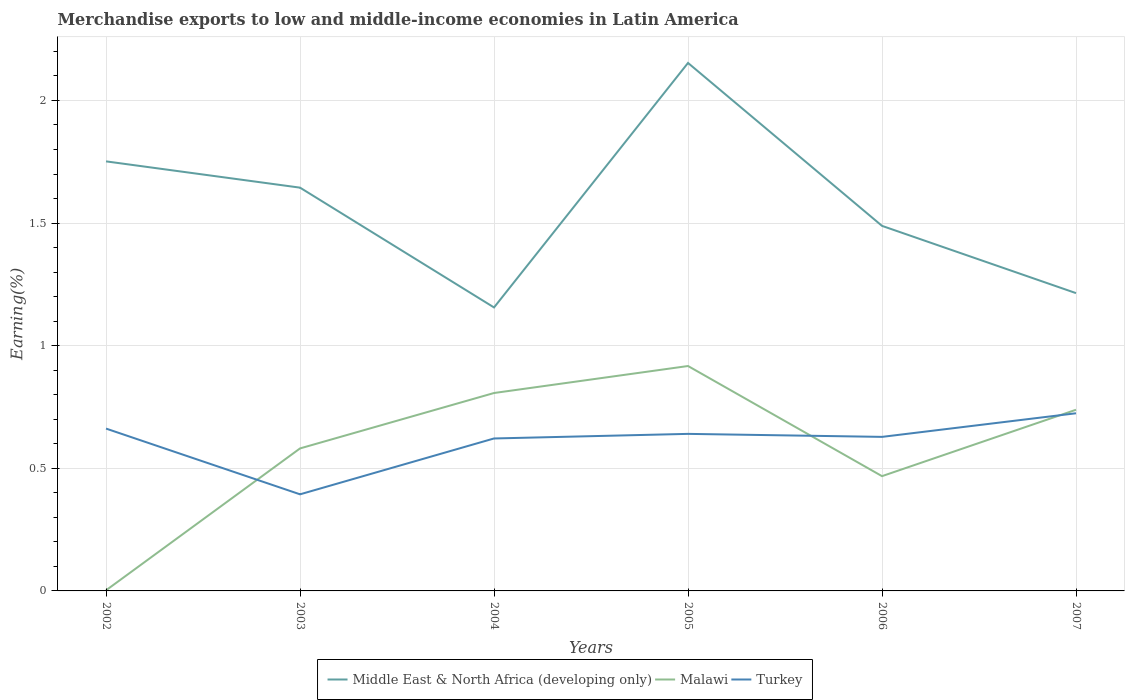How many different coloured lines are there?
Your answer should be very brief. 3. Does the line corresponding to Middle East & North Africa (developing only) intersect with the line corresponding to Malawi?
Keep it short and to the point. No. Across all years, what is the maximum percentage of amount earned from merchandise exports in Turkey?
Provide a short and direct response. 0.39. What is the total percentage of amount earned from merchandise exports in Middle East & North Africa (developing only) in the graph?
Your answer should be very brief. 0.6. What is the difference between the highest and the second highest percentage of amount earned from merchandise exports in Malawi?
Offer a terse response. 0.91. What is the difference between the highest and the lowest percentage of amount earned from merchandise exports in Middle East & North Africa (developing only)?
Provide a short and direct response. 3. Is the percentage of amount earned from merchandise exports in Malawi strictly greater than the percentage of amount earned from merchandise exports in Turkey over the years?
Offer a very short reply. No. How many years are there in the graph?
Provide a succinct answer. 6. What is the difference between two consecutive major ticks on the Y-axis?
Offer a terse response. 0.5. Does the graph contain any zero values?
Your answer should be compact. No. Where does the legend appear in the graph?
Offer a terse response. Bottom center. What is the title of the graph?
Offer a very short reply. Merchandise exports to low and middle-income economies in Latin America. Does "Ghana" appear as one of the legend labels in the graph?
Provide a succinct answer. No. What is the label or title of the Y-axis?
Keep it short and to the point. Earning(%). What is the Earning(%) of Middle East & North Africa (developing only) in 2002?
Make the answer very short. 1.75. What is the Earning(%) of Malawi in 2002?
Keep it short and to the point. 0. What is the Earning(%) of Turkey in 2002?
Give a very brief answer. 0.66. What is the Earning(%) of Middle East & North Africa (developing only) in 2003?
Make the answer very short. 1.64. What is the Earning(%) of Malawi in 2003?
Your answer should be very brief. 0.58. What is the Earning(%) in Turkey in 2003?
Make the answer very short. 0.39. What is the Earning(%) of Middle East & North Africa (developing only) in 2004?
Your answer should be compact. 1.16. What is the Earning(%) in Malawi in 2004?
Your answer should be compact. 0.81. What is the Earning(%) of Turkey in 2004?
Ensure brevity in your answer.  0.62. What is the Earning(%) in Middle East & North Africa (developing only) in 2005?
Provide a short and direct response. 2.15. What is the Earning(%) in Malawi in 2005?
Your answer should be compact. 0.92. What is the Earning(%) of Turkey in 2005?
Your response must be concise. 0.64. What is the Earning(%) of Middle East & North Africa (developing only) in 2006?
Offer a terse response. 1.49. What is the Earning(%) in Malawi in 2006?
Ensure brevity in your answer.  0.47. What is the Earning(%) in Turkey in 2006?
Ensure brevity in your answer.  0.63. What is the Earning(%) of Middle East & North Africa (developing only) in 2007?
Your answer should be compact. 1.21. What is the Earning(%) of Malawi in 2007?
Give a very brief answer. 0.74. What is the Earning(%) in Turkey in 2007?
Keep it short and to the point. 0.72. Across all years, what is the maximum Earning(%) of Middle East & North Africa (developing only)?
Your answer should be compact. 2.15. Across all years, what is the maximum Earning(%) in Malawi?
Keep it short and to the point. 0.92. Across all years, what is the maximum Earning(%) in Turkey?
Provide a short and direct response. 0.72. Across all years, what is the minimum Earning(%) in Middle East & North Africa (developing only)?
Offer a very short reply. 1.16. Across all years, what is the minimum Earning(%) in Malawi?
Offer a very short reply. 0. Across all years, what is the minimum Earning(%) of Turkey?
Ensure brevity in your answer.  0.39. What is the total Earning(%) of Middle East & North Africa (developing only) in the graph?
Offer a very short reply. 9.41. What is the total Earning(%) in Malawi in the graph?
Make the answer very short. 3.51. What is the total Earning(%) of Turkey in the graph?
Your answer should be very brief. 3.67. What is the difference between the Earning(%) in Middle East & North Africa (developing only) in 2002 and that in 2003?
Your answer should be compact. 0.11. What is the difference between the Earning(%) of Malawi in 2002 and that in 2003?
Provide a succinct answer. -0.58. What is the difference between the Earning(%) of Turkey in 2002 and that in 2003?
Give a very brief answer. 0.27. What is the difference between the Earning(%) of Middle East & North Africa (developing only) in 2002 and that in 2004?
Provide a short and direct response. 0.6. What is the difference between the Earning(%) of Malawi in 2002 and that in 2004?
Provide a succinct answer. -0.8. What is the difference between the Earning(%) in Turkey in 2002 and that in 2004?
Offer a very short reply. 0.04. What is the difference between the Earning(%) of Middle East & North Africa (developing only) in 2002 and that in 2005?
Ensure brevity in your answer.  -0.4. What is the difference between the Earning(%) in Malawi in 2002 and that in 2005?
Offer a terse response. -0.91. What is the difference between the Earning(%) in Turkey in 2002 and that in 2005?
Keep it short and to the point. 0.02. What is the difference between the Earning(%) of Middle East & North Africa (developing only) in 2002 and that in 2006?
Offer a terse response. 0.26. What is the difference between the Earning(%) of Malawi in 2002 and that in 2006?
Make the answer very short. -0.47. What is the difference between the Earning(%) of Turkey in 2002 and that in 2006?
Your answer should be very brief. 0.03. What is the difference between the Earning(%) of Middle East & North Africa (developing only) in 2002 and that in 2007?
Your response must be concise. 0.54. What is the difference between the Earning(%) in Malawi in 2002 and that in 2007?
Your answer should be very brief. -0.74. What is the difference between the Earning(%) in Turkey in 2002 and that in 2007?
Ensure brevity in your answer.  -0.06. What is the difference between the Earning(%) in Middle East & North Africa (developing only) in 2003 and that in 2004?
Your response must be concise. 0.49. What is the difference between the Earning(%) of Malawi in 2003 and that in 2004?
Your answer should be very brief. -0.23. What is the difference between the Earning(%) in Turkey in 2003 and that in 2004?
Provide a short and direct response. -0.23. What is the difference between the Earning(%) in Middle East & North Africa (developing only) in 2003 and that in 2005?
Provide a short and direct response. -0.51. What is the difference between the Earning(%) in Malawi in 2003 and that in 2005?
Your answer should be compact. -0.34. What is the difference between the Earning(%) of Turkey in 2003 and that in 2005?
Provide a succinct answer. -0.25. What is the difference between the Earning(%) in Middle East & North Africa (developing only) in 2003 and that in 2006?
Provide a short and direct response. 0.16. What is the difference between the Earning(%) of Malawi in 2003 and that in 2006?
Provide a short and direct response. 0.11. What is the difference between the Earning(%) in Turkey in 2003 and that in 2006?
Provide a succinct answer. -0.23. What is the difference between the Earning(%) in Middle East & North Africa (developing only) in 2003 and that in 2007?
Provide a short and direct response. 0.43. What is the difference between the Earning(%) in Malawi in 2003 and that in 2007?
Make the answer very short. -0.16. What is the difference between the Earning(%) of Turkey in 2003 and that in 2007?
Give a very brief answer. -0.33. What is the difference between the Earning(%) of Middle East & North Africa (developing only) in 2004 and that in 2005?
Keep it short and to the point. -1. What is the difference between the Earning(%) of Malawi in 2004 and that in 2005?
Your answer should be very brief. -0.11. What is the difference between the Earning(%) in Turkey in 2004 and that in 2005?
Your answer should be very brief. -0.02. What is the difference between the Earning(%) in Middle East & North Africa (developing only) in 2004 and that in 2006?
Your answer should be compact. -0.33. What is the difference between the Earning(%) of Malawi in 2004 and that in 2006?
Provide a short and direct response. 0.34. What is the difference between the Earning(%) of Turkey in 2004 and that in 2006?
Provide a short and direct response. -0.01. What is the difference between the Earning(%) of Middle East & North Africa (developing only) in 2004 and that in 2007?
Provide a succinct answer. -0.06. What is the difference between the Earning(%) in Malawi in 2004 and that in 2007?
Offer a terse response. 0.07. What is the difference between the Earning(%) in Turkey in 2004 and that in 2007?
Your answer should be very brief. -0.1. What is the difference between the Earning(%) of Middle East & North Africa (developing only) in 2005 and that in 2006?
Keep it short and to the point. 0.66. What is the difference between the Earning(%) in Malawi in 2005 and that in 2006?
Give a very brief answer. 0.45. What is the difference between the Earning(%) in Turkey in 2005 and that in 2006?
Provide a succinct answer. 0.01. What is the difference between the Earning(%) in Middle East & North Africa (developing only) in 2005 and that in 2007?
Your answer should be compact. 0.94. What is the difference between the Earning(%) of Malawi in 2005 and that in 2007?
Give a very brief answer. 0.18. What is the difference between the Earning(%) of Turkey in 2005 and that in 2007?
Offer a very short reply. -0.08. What is the difference between the Earning(%) of Middle East & North Africa (developing only) in 2006 and that in 2007?
Offer a terse response. 0.27. What is the difference between the Earning(%) of Malawi in 2006 and that in 2007?
Ensure brevity in your answer.  -0.27. What is the difference between the Earning(%) in Turkey in 2006 and that in 2007?
Provide a succinct answer. -0.1. What is the difference between the Earning(%) of Middle East & North Africa (developing only) in 2002 and the Earning(%) of Malawi in 2003?
Ensure brevity in your answer.  1.17. What is the difference between the Earning(%) in Middle East & North Africa (developing only) in 2002 and the Earning(%) in Turkey in 2003?
Provide a short and direct response. 1.36. What is the difference between the Earning(%) in Malawi in 2002 and the Earning(%) in Turkey in 2003?
Your response must be concise. -0.39. What is the difference between the Earning(%) of Middle East & North Africa (developing only) in 2002 and the Earning(%) of Malawi in 2004?
Your answer should be compact. 0.94. What is the difference between the Earning(%) of Middle East & North Africa (developing only) in 2002 and the Earning(%) of Turkey in 2004?
Your answer should be compact. 1.13. What is the difference between the Earning(%) of Malawi in 2002 and the Earning(%) of Turkey in 2004?
Your response must be concise. -0.62. What is the difference between the Earning(%) in Middle East & North Africa (developing only) in 2002 and the Earning(%) in Malawi in 2005?
Ensure brevity in your answer.  0.83. What is the difference between the Earning(%) in Middle East & North Africa (developing only) in 2002 and the Earning(%) in Turkey in 2005?
Keep it short and to the point. 1.11. What is the difference between the Earning(%) in Malawi in 2002 and the Earning(%) in Turkey in 2005?
Offer a very short reply. -0.64. What is the difference between the Earning(%) in Middle East & North Africa (developing only) in 2002 and the Earning(%) in Malawi in 2006?
Ensure brevity in your answer.  1.28. What is the difference between the Earning(%) of Middle East & North Africa (developing only) in 2002 and the Earning(%) of Turkey in 2006?
Make the answer very short. 1.12. What is the difference between the Earning(%) in Malawi in 2002 and the Earning(%) in Turkey in 2006?
Offer a very short reply. -0.63. What is the difference between the Earning(%) in Middle East & North Africa (developing only) in 2002 and the Earning(%) in Malawi in 2007?
Provide a succinct answer. 1.01. What is the difference between the Earning(%) in Middle East & North Africa (developing only) in 2002 and the Earning(%) in Turkey in 2007?
Offer a terse response. 1.03. What is the difference between the Earning(%) of Malawi in 2002 and the Earning(%) of Turkey in 2007?
Provide a succinct answer. -0.72. What is the difference between the Earning(%) in Middle East & North Africa (developing only) in 2003 and the Earning(%) in Malawi in 2004?
Your answer should be compact. 0.84. What is the difference between the Earning(%) of Middle East & North Africa (developing only) in 2003 and the Earning(%) of Turkey in 2004?
Your response must be concise. 1.02. What is the difference between the Earning(%) in Malawi in 2003 and the Earning(%) in Turkey in 2004?
Keep it short and to the point. -0.04. What is the difference between the Earning(%) in Middle East & North Africa (developing only) in 2003 and the Earning(%) in Malawi in 2005?
Provide a succinct answer. 0.73. What is the difference between the Earning(%) in Middle East & North Africa (developing only) in 2003 and the Earning(%) in Turkey in 2005?
Your answer should be compact. 1. What is the difference between the Earning(%) in Malawi in 2003 and the Earning(%) in Turkey in 2005?
Your answer should be compact. -0.06. What is the difference between the Earning(%) of Middle East & North Africa (developing only) in 2003 and the Earning(%) of Malawi in 2006?
Give a very brief answer. 1.18. What is the difference between the Earning(%) of Middle East & North Africa (developing only) in 2003 and the Earning(%) of Turkey in 2006?
Make the answer very short. 1.02. What is the difference between the Earning(%) of Malawi in 2003 and the Earning(%) of Turkey in 2006?
Keep it short and to the point. -0.05. What is the difference between the Earning(%) in Middle East & North Africa (developing only) in 2003 and the Earning(%) in Malawi in 2007?
Provide a short and direct response. 0.91. What is the difference between the Earning(%) of Malawi in 2003 and the Earning(%) of Turkey in 2007?
Your answer should be compact. -0.14. What is the difference between the Earning(%) in Middle East & North Africa (developing only) in 2004 and the Earning(%) in Malawi in 2005?
Ensure brevity in your answer.  0.24. What is the difference between the Earning(%) in Middle East & North Africa (developing only) in 2004 and the Earning(%) in Turkey in 2005?
Give a very brief answer. 0.52. What is the difference between the Earning(%) of Malawi in 2004 and the Earning(%) of Turkey in 2005?
Provide a succinct answer. 0.17. What is the difference between the Earning(%) of Middle East & North Africa (developing only) in 2004 and the Earning(%) of Malawi in 2006?
Your response must be concise. 0.69. What is the difference between the Earning(%) in Middle East & North Africa (developing only) in 2004 and the Earning(%) in Turkey in 2006?
Provide a short and direct response. 0.53. What is the difference between the Earning(%) of Malawi in 2004 and the Earning(%) of Turkey in 2006?
Your answer should be compact. 0.18. What is the difference between the Earning(%) in Middle East & North Africa (developing only) in 2004 and the Earning(%) in Malawi in 2007?
Give a very brief answer. 0.42. What is the difference between the Earning(%) in Middle East & North Africa (developing only) in 2004 and the Earning(%) in Turkey in 2007?
Offer a very short reply. 0.43. What is the difference between the Earning(%) in Malawi in 2004 and the Earning(%) in Turkey in 2007?
Keep it short and to the point. 0.08. What is the difference between the Earning(%) of Middle East & North Africa (developing only) in 2005 and the Earning(%) of Malawi in 2006?
Your response must be concise. 1.69. What is the difference between the Earning(%) in Middle East & North Africa (developing only) in 2005 and the Earning(%) in Turkey in 2006?
Provide a succinct answer. 1.52. What is the difference between the Earning(%) of Malawi in 2005 and the Earning(%) of Turkey in 2006?
Your answer should be very brief. 0.29. What is the difference between the Earning(%) in Middle East & North Africa (developing only) in 2005 and the Earning(%) in Malawi in 2007?
Offer a terse response. 1.41. What is the difference between the Earning(%) of Middle East & North Africa (developing only) in 2005 and the Earning(%) of Turkey in 2007?
Offer a terse response. 1.43. What is the difference between the Earning(%) in Malawi in 2005 and the Earning(%) in Turkey in 2007?
Make the answer very short. 0.19. What is the difference between the Earning(%) in Middle East & North Africa (developing only) in 2006 and the Earning(%) in Malawi in 2007?
Offer a terse response. 0.75. What is the difference between the Earning(%) in Middle East & North Africa (developing only) in 2006 and the Earning(%) in Turkey in 2007?
Keep it short and to the point. 0.76. What is the difference between the Earning(%) in Malawi in 2006 and the Earning(%) in Turkey in 2007?
Offer a terse response. -0.26. What is the average Earning(%) of Middle East & North Africa (developing only) per year?
Your answer should be very brief. 1.57. What is the average Earning(%) of Malawi per year?
Provide a succinct answer. 0.59. What is the average Earning(%) in Turkey per year?
Offer a terse response. 0.61. In the year 2002, what is the difference between the Earning(%) of Middle East & North Africa (developing only) and Earning(%) of Malawi?
Your response must be concise. 1.75. In the year 2002, what is the difference between the Earning(%) of Middle East & North Africa (developing only) and Earning(%) of Turkey?
Keep it short and to the point. 1.09. In the year 2002, what is the difference between the Earning(%) of Malawi and Earning(%) of Turkey?
Ensure brevity in your answer.  -0.66. In the year 2003, what is the difference between the Earning(%) in Middle East & North Africa (developing only) and Earning(%) in Malawi?
Offer a very short reply. 1.06. In the year 2003, what is the difference between the Earning(%) in Middle East & North Africa (developing only) and Earning(%) in Turkey?
Give a very brief answer. 1.25. In the year 2003, what is the difference between the Earning(%) of Malawi and Earning(%) of Turkey?
Keep it short and to the point. 0.19. In the year 2004, what is the difference between the Earning(%) of Middle East & North Africa (developing only) and Earning(%) of Malawi?
Your answer should be very brief. 0.35. In the year 2004, what is the difference between the Earning(%) in Middle East & North Africa (developing only) and Earning(%) in Turkey?
Offer a terse response. 0.53. In the year 2004, what is the difference between the Earning(%) in Malawi and Earning(%) in Turkey?
Provide a succinct answer. 0.19. In the year 2005, what is the difference between the Earning(%) of Middle East & North Africa (developing only) and Earning(%) of Malawi?
Make the answer very short. 1.24. In the year 2005, what is the difference between the Earning(%) of Middle East & North Africa (developing only) and Earning(%) of Turkey?
Keep it short and to the point. 1.51. In the year 2005, what is the difference between the Earning(%) of Malawi and Earning(%) of Turkey?
Keep it short and to the point. 0.28. In the year 2006, what is the difference between the Earning(%) of Middle East & North Africa (developing only) and Earning(%) of Malawi?
Provide a succinct answer. 1.02. In the year 2006, what is the difference between the Earning(%) of Middle East & North Africa (developing only) and Earning(%) of Turkey?
Give a very brief answer. 0.86. In the year 2006, what is the difference between the Earning(%) of Malawi and Earning(%) of Turkey?
Your response must be concise. -0.16. In the year 2007, what is the difference between the Earning(%) in Middle East & North Africa (developing only) and Earning(%) in Malawi?
Your response must be concise. 0.48. In the year 2007, what is the difference between the Earning(%) of Middle East & North Africa (developing only) and Earning(%) of Turkey?
Keep it short and to the point. 0.49. In the year 2007, what is the difference between the Earning(%) in Malawi and Earning(%) in Turkey?
Make the answer very short. 0.01. What is the ratio of the Earning(%) of Middle East & North Africa (developing only) in 2002 to that in 2003?
Keep it short and to the point. 1.07. What is the ratio of the Earning(%) of Malawi in 2002 to that in 2003?
Keep it short and to the point. 0. What is the ratio of the Earning(%) of Turkey in 2002 to that in 2003?
Provide a short and direct response. 1.68. What is the ratio of the Earning(%) of Middle East & North Africa (developing only) in 2002 to that in 2004?
Your answer should be very brief. 1.52. What is the ratio of the Earning(%) of Malawi in 2002 to that in 2004?
Offer a terse response. 0. What is the ratio of the Earning(%) of Turkey in 2002 to that in 2004?
Offer a terse response. 1.06. What is the ratio of the Earning(%) of Middle East & North Africa (developing only) in 2002 to that in 2005?
Make the answer very short. 0.81. What is the ratio of the Earning(%) in Malawi in 2002 to that in 2005?
Your response must be concise. 0. What is the ratio of the Earning(%) of Turkey in 2002 to that in 2005?
Make the answer very short. 1.03. What is the ratio of the Earning(%) in Middle East & North Africa (developing only) in 2002 to that in 2006?
Provide a short and direct response. 1.18. What is the ratio of the Earning(%) of Malawi in 2002 to that in 2006?
Ensure brevity in your answer.  0.01. What is the ratio of the Earning(%) in Turkey in 2002 to that in 2006?
Ensure brevity in your answer.  1.05. What is the ratio of the Earning(%) of Middle East & North Africa (developing only) in 2002 to that in 2007?
Your response must be concise. 1.44. What is the ratio of the Earning(%) of Malawi in 2002 to that in 2007?
Offer a very short reply. 0. What is the ratio of the Earning(%) of Turkey in 2002 to that in 2007?
Keep it short and to the point. 0.91. What is the ratio of the Earning(%) in Middle East & North Africa (developing only) in 2003 to that in 2004?
Provide a succinct answer. 1.42. What is the ratio of the Earning(%) of Malawi in 2003 to that in 2004?
Your response must be concise. 0.72. What is the ratio of the Earning(%) of Turkey in 2003 to that in 2004?
Provide a short and direct response. 0.63. What is the ratio of the Earning(%) in Middle East & North Africa (developing only) in 2003 to that in 2005?
Make the answer very short. 0.76. What is the ratio of the Earning(%) of Malawi in 2003 to that in 2005?
Keep it short and to the point. 0.63. What is the ratio of the Earning(%) in Turkey in 2003 to that in 2005?
Ensure brevity in your answer.  0.62. What is the ratio of the Earning(%) in Middle East & North Africa (developing only) in 2003 to that in 2006?
Your answer should be very brief. 1.1. What is the ratio of the Earning(%) in Malawi in 2003 to that in 2006?
Make the answer very short. 1.24. What is the ratio of the Earning(%) in Turkey in 2003 to that in 2006?
Your answer should be very brief. 0.63. What is the ratio of the Earning(%) in Middle East & North Africa (developing only) in 2003 to that in 2007?
Your answer should be compact. 1.35. What is the ratio of the Earning(%) in Malawi in 2003 to that in 2007?
Your answer should be compact. 0.79. What is the ratio of the Earning(%) in Turkey in 2003 to that in 2007?
Make the answer very short. 0.54. What is the ratio of the Earning(%) of Middle East & North Africa (developing only) in 2004 to that in 2005?
Make the answer very short. 0.54. What is the ratio of the Earning(%) in Turkey in 2004 to that in 2005?
Your answer should be compact. 0.97. What is the ratio of the Earning(%) in Middle East & North Africa (developing only) in 2004 to that in 2006?
Offer a very short reply. 0.78. What is the ratio of the Earning(%) in Malawi in 2004 to that in 2006?
Your response must be concise. 1.72. What is the ratio of the Earning(%) in Turkey in 2004 to that in 2006?
Provide a succinct answer. 0.99. What is the ratio of the Earning(%) of Middle East & North Africa (developing only) in 2004 to that in 2007?
Offer a very short reply. 0.95. What is the ratio of the Earning(%) in Malawi in 2004 to that in 2007?
Your answer should be very brief. 1.09. What is the ratio of the Earning(%) of Turkey in 2004 to that in 2007?
Make the answer very short. 0.86. What is the ratio of the Earning(%) of Middle East & North Africa (developing only) in 2005 to that in 2006?
Provide a short and direct response. 1.45. What is the ratio of the Earning(%) of Malawi in 2005 to that in 2006?
Provide a succinct answer. 1.96. What is the ratio of the Earning(%) of Turkey in 2005 to that in 2006?
Your answer should be compact. 1.02. What is the ratio of the Earning(%) of Middle East & North Africa (developing only) in 2005 to that in 2007?
Offer a very short reply. 1.77. What is the ratio of the Earning(%) in Malawi in 2005 to that in 2007?
Your answer should be very brief. 1.24. What is the ratio of the Earning(%) in Turkey in 2005 to that in 2007?
Give a very brief answer. 0.88. What is the ratio of the Earning(%) of Middle East & North Africa (developing only) in 2006 to that in 2007?
Your response must be concise. 1.23. What is the ratio of the Earning(%) in Malawi in 2006 to that in 2007?
Ensure brevity in your answer.  0.63. What is the ratio of the Earning(%) of Turkey in 2006 to that in 2007?
Provide a short and direct response. 0.87. What is the difference between the highest and the second highest Earning(%) of Middle East & North Africa (developing only)?
Ensure brevity in your answer.  0.4. What is the difference between the highest and the second highest Earning(%) of Malawi?
Provide a succinct answer. 0.11. What is the difference between the highest and the second highest Earning(%) in Turkey?
Your response must be concise. 0.06. What is the difference between the highest and the lowest Earning(%) of Middle East & North Africa (developing only)?
Give a very brief answer. 1. What is the difference between the highest and the lowest Earning(%) of Malawi?
Offer a very short reply. 0.91. What is the difference between the highest and the lowest Earning(%) in Turkey?
Your response must be concise. 0.33. 